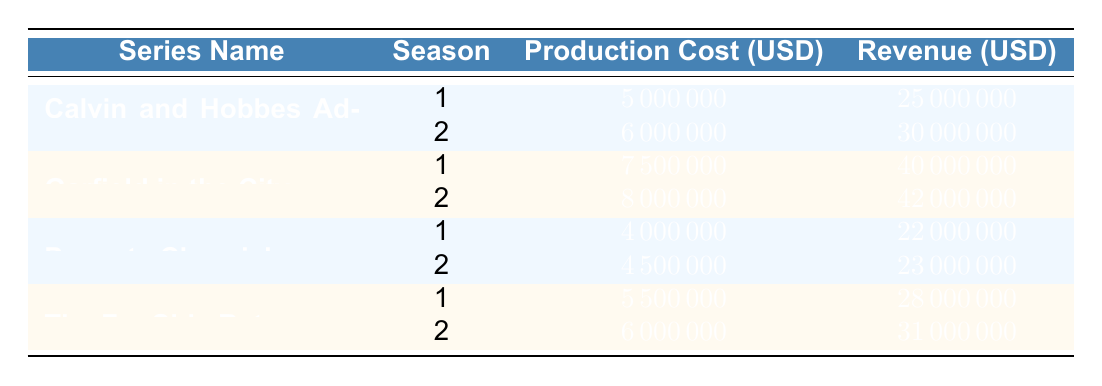What is the production cost for the first season of "Calvin and Hobbes Adventures"? According to the table, the production cost for the first season of "Calvin and Hobbes Adventures" is listed as 5,000,000 USD.
Answer: 5,000,000 USD What is the total revenue generated by "Garfield in the City" across both seasons? To find the total revenue for "Garfield in the City," add the revenue for both seasons: 40,000,000 USD (Season 1) + 42,000,000 USD (Season 2) = 82,000,000 USD.
Answer: 82,000,000 USD Did "Peanuts Chronicles" generate more revenue in Season 2 than in Season 1? Comparing the revenues, "Peanuts Chronicles" had 23,000,000 USD in Season 2 and 22,000,000 USD in Season 1; therefore, it did generate more revenue in Season 2.
Answer: Yes What is the average production cost for all series in Season 2? Summing the production costs for all series in Season 2 gives: 6,000,000 (Calvin and Hobbes) + 8,000,000 (Garfield) + 4,500,000 (Peanuts) + 6,000,000 (Far Side) = 24,500,000 USD. Dividing by the number of series (4) gives an average of 6,125,000 USD.
Answer: 6,125,000 USD Is it true that "The Far Side Returns" had a lower production cost than "Garfield in the City" in both seasons? In Season 1, "Garfield in the City" had a production cost of 7,500,000 USD, while "The Far Side Returns" had a production cost of 5,500,000 USD. In Season 2, "Garfield" had 8,000,000 USD, while "The Far Side" had 6,000,000 USD. Therefore, it is true that "The Far Side Returns" had a lower production cost in both seasons.
Answer: Yes 